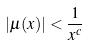Convert formula to latex. <formula><loc_0><loc_0><loc_500><loc_500>| \mu ( x ) | < \frac { 1 } { x ^ { c } }</formula> 